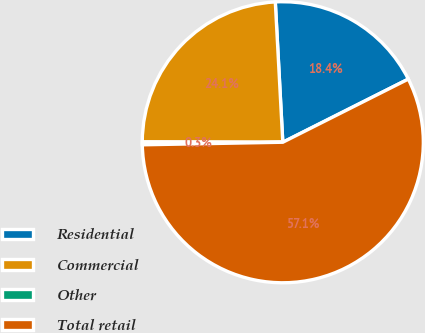Convert chart to OTSL. <chart><loc_0><loc_0><loc_500><loc_500><pie_chart><fcel>Residential<fcel>Commercial<fcel>Other<fcel>Total retail<nl><fcel>18.43%<fcel>24.11%<fcel>0.33%<fcel>57.13%<nl></chart> 